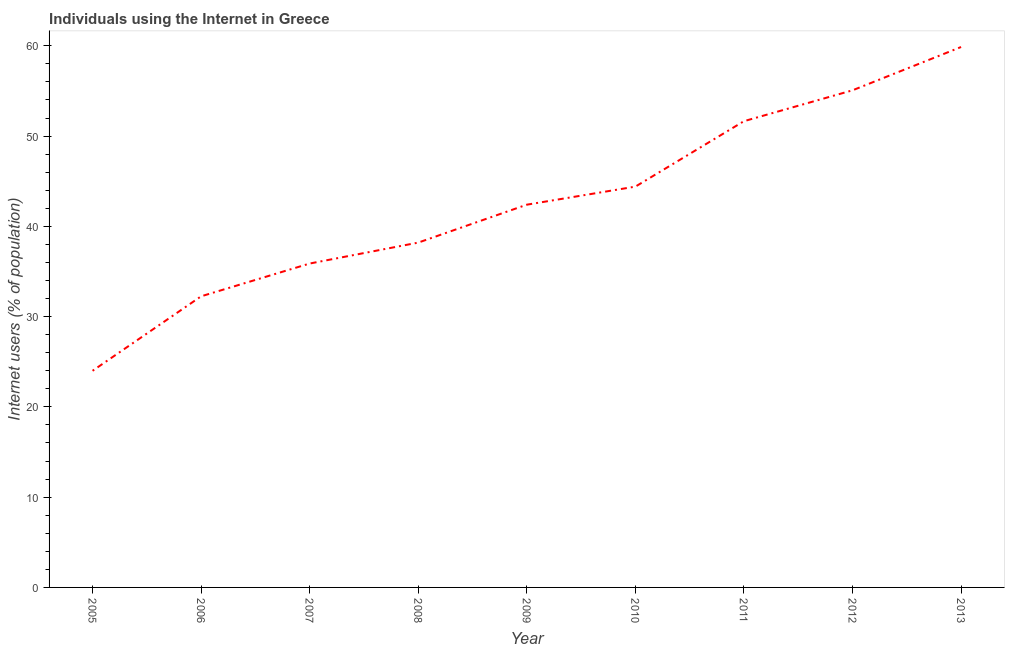What is the number of internet users in 2013?
Provide a succinct answer. 59.87. Across all years, what is the maximum number of internet users?
Provide a short and direct response. 59.87. Across all years, what is the minimum number of internet users?
Keep it short and to the point. 24. What is the sum of the number of internet users?
Provide a succinct answer. 383.72. What is the difference between the number of internet users in 2008 and 2011?
Your answer should be very brief. -13.45. What is the average number of internet users per year?
Provide a succinct answer. 42.64. What is the median number of internet users?
Ensure brevity in your answer.  42.4. Do a majority of the years between 2013 and 2007 (inclusive) have number of internet users greater than 54 %?
Offer a terse response. Yes. What is the ratio of the number of internet users in 2012 to that in 2013?
Give a very brief answer. 0.92. Is the number of internet users in 2010 less than that in 2011?
Give a very brief answer. Yes. Is the difference between the number of internet users in 2005 and 2011 greater than the difference between any two years?
Your response must be concise. No. What is the difference between the highest and the second highest number of internet users?
Make the answer very short. 4.8. What is the difference between the highest and the lowest number of internet users?
Make the answer very short. 35.87. How many lines are there?
Keep it short and to the point. 1. How many years are there in the graph?
Ensure brevity in your answer.  9. Are the values on the major ticks of Y-axis written in scientific E-notation?
Keep it short and to the point. No. Does the graph contain grids?
Provide a short and direct response. No. What is the title of the graph?
Make the answer very short. Individuals using the Internet in Greece. What is the label or title of the Y-axis?
Your response must be concise. Internet users (% of population). What is the Internet users (% of population) of 2005?
Offer a very short reply. 24. What is the Internet users (% of population) in 2006?
Keep it short and to the point. 32.25. What is the Internet users (% of population) in 2007?
Make the answer very short. 35.88. What is the Internet users (% of population) of 2008?
Your response must be concise. 38.2. What is the Internet users (% of population) in 2009?
Keep it short and to the point. 42.4. What is the Internet users (% of population) of 2010?
Your response must be concise. 44.4. What is the Internet users (% of population) in 2011?
Provide a short and direct response. 51.65. What is the Internet users (% of population) in 2012?
Ensure brevity in your answer.  55.07. What is the Internet users (% of population) in 2013?
Offer a terse response. 59.87. What is the difference between the Internet users (% of population) in 2005 and 2006?
Offer a terse response. -8.25. What is the difference between the Internet users (% of population) in 2005 and 2007?
Ensure brevity in your answer.  -11.88. What is the difference between the Internet users (% of population) in 2005 and 2009?
Provide a succinct answer. -18.4. What is the difference between the Internet users (% of population) in 2005 and 2010?
Give a very brief answer. -20.4. What is the difference between the Internet users (% of population) in 2005 and 2011?
Your response must be concise. -27.65. What is the difference between the Internet users (% of population) in 2005 and 2012?
Provide a succinct answer. -31.07. What is the difference between the Internet users (% of population) in 2005 and 2013?
Keep it short and to the point. -35.87. What is the difference between the Internet users (% of population) in 2006 and 2007?
Provide a succinct answer. -3.63. What is the difference between the Internet users (% of population) in 2006 and 2008?
Offer a terse response. -5.95. What is the difference between the Internet users (% of population) in 2006 and 2009?
Give a very brief answer. -10.15. What is the difference between the Internet users (% of population) in 2006 and 2010?
Give a very brief answer. -12.15. What is the difference between the Internet users (% of population) in 2006 and 2011?
Provide a short and direct response. -19.4. What is the difference between the Internet users (% of population) in 2006 and 2012?
Offer a very short reply. -22.82. What is the difference between the Internet users (% of population) in 2006 and 2013?
Offer a terse response. -27.62. What is the difference between the Internet users (% of population) in 2007 and 2008?
Your response must be concise. -2.32. What is the difference between the Internet users (% of population) in 2007 and 2009?
Provide a succinct answer. -6.52. What is the difference between the Internet users (% of population) in 2007 and 2010?
Provide a succinct answer. -8.52. What is the difference between the Internet users (% of population) in 2007 and 2011?
Give a very brief answer. -15.77. What is the difference between the Internet users (% of population) in 2007 and 2012?
Offer a very short reply. -19.19. What is the difference between the Internet users (% of population) in 2007 and 2013?
Your answer should be very brief. -23.99. What is the difference between the Internet users (% of population) in 2008 and 2009?
Provide a short and direct response. -4.2. What is the difference between the Internet users (% of population) in 2008 and 2011?
Give a very brief answer. -13.45. What is the difference between the Internet users (% of population) in 2008 and 2012?
Offer a very short reply. -16.87. What is the difference between the Internet users (% of population) in 2008 and 2013?
Provide a short and direct response. -21.67. What is the difference between the Internet users (% of population) in 2009 and 2011?
Give a very brief answer. -9.25. What is the difference between the Internet users (% of population) in 2009 and 2012?
Provide a succinct answer. -12.67. What is the difference between the Internet users (% of population) in 2009 and 2013?
Keep it short and to the point. -17.47. What is the difference between the Internet users (% of population) in 2010 and 2011?
Make the answer very short. -7.25. What is the difference between the Internet users (% of population) in 2010 and 2012?
Offer a very short reply. -10.67. What is the difference between the Internet users (% of population) in 2010 and 2013?
Give a very brief answer. -15.47. What is the difference between the Internet users (% of population) in 2011 and 2012?
Your answer should be very brief. -3.42. What is the difference between the Internet users (% of population) in 2011 and 2013?
Offer a terse response. -8.22. What is the difference between the Internet users (% of population) in 2012 and 2013?
Your answer should be compact. -4.8. What is the ratio of the Internet users (% of population) in 2005 to that in 2006?
Make the answer very short. 0.74. What is the ratio of the Internet users (% of population) in 2005 to that in 2007?
Offer a very short reply. 0.67. What is the ratio of the Internet users (% of population) in 2005 to that in 2008?
Keep it short and to the point. 0.63. What is the ratio of the Internet users (% of population) in 2005 to that in 2009?
Your response must be concise. 0.57. What is the ratio of the Internet users (% of population) in 2005 to that in 2010?
Offer a very short reply. 0.54. What is the ratio of the Internet users (% of population) in 2005 to that in 2011?
Offer a terse response. 0.47. What is the ratio of the Internet users (% of population) in 2005 to that in 2012?
Keep it short and to the point. 0.44. What is the ratio of the Internet users (% of population) in 2005 to that in 2013?
Make the answer very short. 0.4. What is the ratio of the Internet users (% of population) in 2006 to that in 2007?
Provide a succinct answer. 0.9. What is the ratio of the Internet users (% of population) in 2006 to that in 2008?
Your response must be concise. 0.84. What is the ratio of the Internet users (% of population) in 2006 to that in 2009?
Your answer should be very brief. 0.76. What is the ratio of the Internet users (% of population) in 2006 to that in 2010?
Your response must be concise. 0.73. What is the ratio of the Internet users (% of population) in 2006 to that in 2011?
Give a very brief answer. 0.62. What is the ratio of the Internet users (% of population) in 2006 to that in 2012?
Your response must be concise. 0.59. What is the ratio of the Internet users (% of population) in 2006 to that in 2013?
Offer a very short reply. 0.54. What is the ratio of the Internet users (% of population) in 2007 to that in 2008?
Offer a terse response. 0.94. What is the ratio of the Internet users (% of population) in 2007 to that in 2009?
Provide a succinct answer. 0.85. What is the ratio of the Internet users (% of population) in 2007 to that in 2010?
Make the answer very short. 0.81. What is the ratio of the Internet users (% of population) in 2007 to that in 2011?
Give a very brief answer. 0.69. What is the ratio of the Internet users (% of population) in 2007 to that in 2012?
Offer a terse response. 0.65. What is the ratio of the Internet users (% of population) in 2007 to that in 2013?
Provide a succinct answer. 0.6. What is the ratio of the Internet users (% of population) in 2008 to that in 2009?
Offer a very short reply. 0.9. What is the ratio of the Internet users (% of population) in 2008 to that in 2010?
Keep it short and to the point. 0.86. What is the ratio of the Internet users (% of population) in 2008 to that in 2011?
Provide a short and direct response. 0.74. What is the ratio of the Internet users (% of population) in 2008 to that in 2012?
Your response must be concise. 0.69. What is the ratio of the Internet users (% of population) in 2008 to that in 2013?
Provide a succinct answer. 0.64. What is the ratio of the Internet users (% of population) in 2009 to that in 2010?
Offer a terse response. 0.95. What is the ratio of the Internet users (% of population) in 2009 to that in 2011?
Offer a very short reply. 0.82. What is the ratio of the Internet users (% of population) in 2009 to that in 2012?
Keep it short and to the point. 0.77. What is the ratio of the Internet users (% of population) in 2009 to that in 2013?
Give a very brief answer. 0.71. What is the ratio of the Internet users (% of population) in 2010 to that in 2011?
Keep it short and to the point. 0.86. What is the ratio of the Internet users (% of population) in 2010 to that in 2012?
Provide a succinct answer. 0.81. What is the ratio of the Internet users (% of population) in 2010 to that in 2013?
Offer a very short reply. 0.74. What is the ratio of the Internet users (% of population) in 2011 to that in 2012?
Give a very brief answer. 0.94. What is the ratio of the Internet users (% of population) in 2011 to that in 2013?
Offer a very short reply. 0.86. 